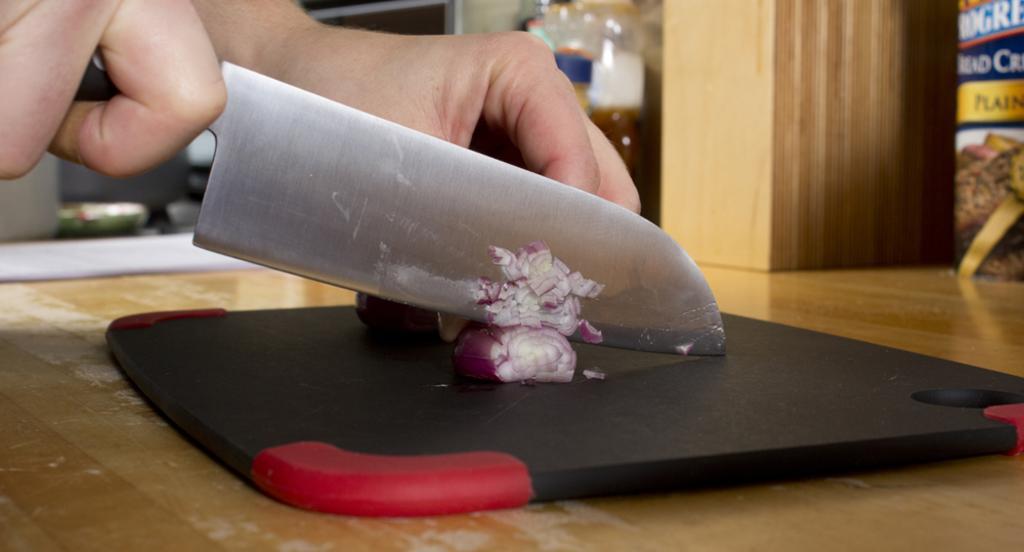In one or two sentences, can you explain what this image depicts? In this picture we can see a human hand cutting an onion with the knife on the knife pad. This is the table. 